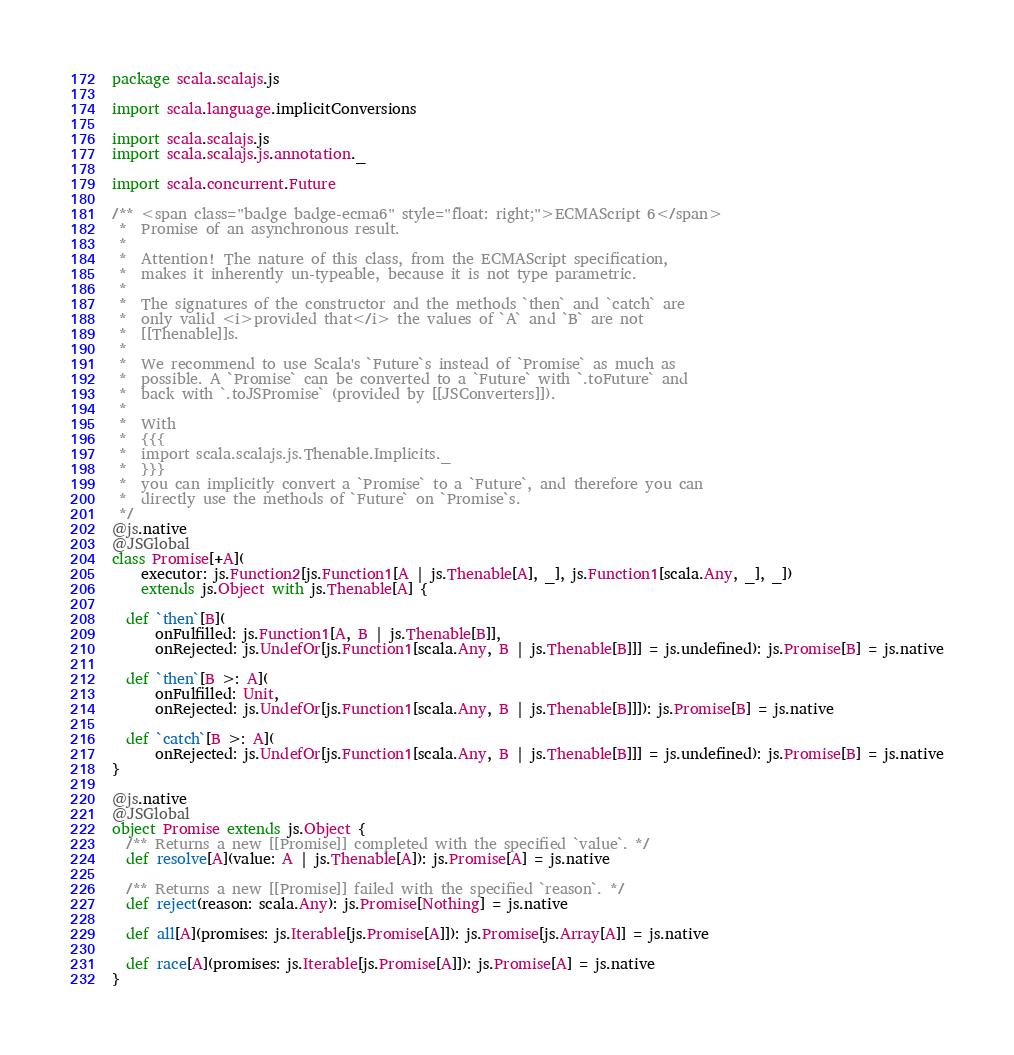Convert code to text. <code><loc_0><loc_0><loc_500><loc_500><_Scala_>
package scala.scalajs.js

import scala.language.implicitConversions

import scala.scalajs.js
import scala.scalajs.js.annotation._

import scala.concurrent.Future

/** <span class="badge badge-ecma6" style="float: right;">ECMAScript 6</span>
 *  Promise of an asynchronous result.
 *
 *  Attention! The nature of this class, from the ECMAScript specification,
 *  makes it inherently un-typeable, because it is not type parametric.
 *
 *  The signatures of the constructor and the methods `then` and `catch` are
 *  only valid <i>provided that</i> the values of `A` and `B` are not
 *  [[Thenable]]s.
 *
 *  We recommend to use Scala's `Future`s instead of `Promise` as much as
 *  possible. A `Promise` can be converted to a `Future` with `.toFuture` and
 *  back with `.toJSPromise` (provided by [[JSConverters]]).
 *
 *  With
 *  {{{
 *  import scala.scalajs.js.Thenable.Implicits._
 *  }}}
 *  you can implicitly convert a `Promise` to a `Future`, and therefore you can
 *  directly use the methods of `Future` on `Promise`s.
 */
@js.native
@JSGlobal
class Promise[+A](
    executor: js.Function2[js.Function1[A | js.Thenable[A], _], js.Function1[scala.Any, _], _])
    extends js.Object with js.Thenable[A] {

  def `then`[B](
      onFulfilled: js.Function1[A, B | js.Thenable[B]],
      onRejected: js.UndefOr[js.Function1[scala.Any, B | js.Thenable[B]]] = js.undefined): js.Promise[B] = js.native

  def `then`[B >: A](
      onFulfilled: Unit,
      onRejected: js.UndefOr[js.Function1[scala.Any, B | js.Thenable[B]]]): js.Promise[B] = js.native

  def `catch`[B >: A](
      onRejected: js.UndefOr[js.Function1[scala.Any, B | js.Thenable[B]]] = js.undefined): js.Promise[B] = js.native
}

@js.native
@JSGlobal
object Promise extends js.Object {
  /** Returns a new [[Promise]] completed with the specified `value`. */
  def resolve[A](value: A | js.Thenable[A]): js.Promise[A] = js.native

  /** Returns a new [[Promise]] failed with the specified `reason`. */
  def reject(reason: scala.Any): js.Promise[Nothing] = js.native

  def all[A](promises: js.Iterable[js.Promise[A]]): js.Promise[js.Array[A]] = js.native

  def race[A](promises: js.Iterable[js.Promise[A]]): js.Promise[A] = js.native
}
</code> 